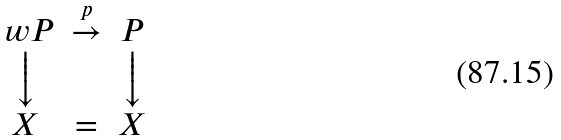<formula> <loc_0><loc_0><loc_500><loc_500>\begin{array} { c c c } \ w { P } & \stackrel { p } { \rightarrow } & P \\ \Big \downarrow & & \Big \downarrow \\ X & = & X \\ \end{array}</formula> 